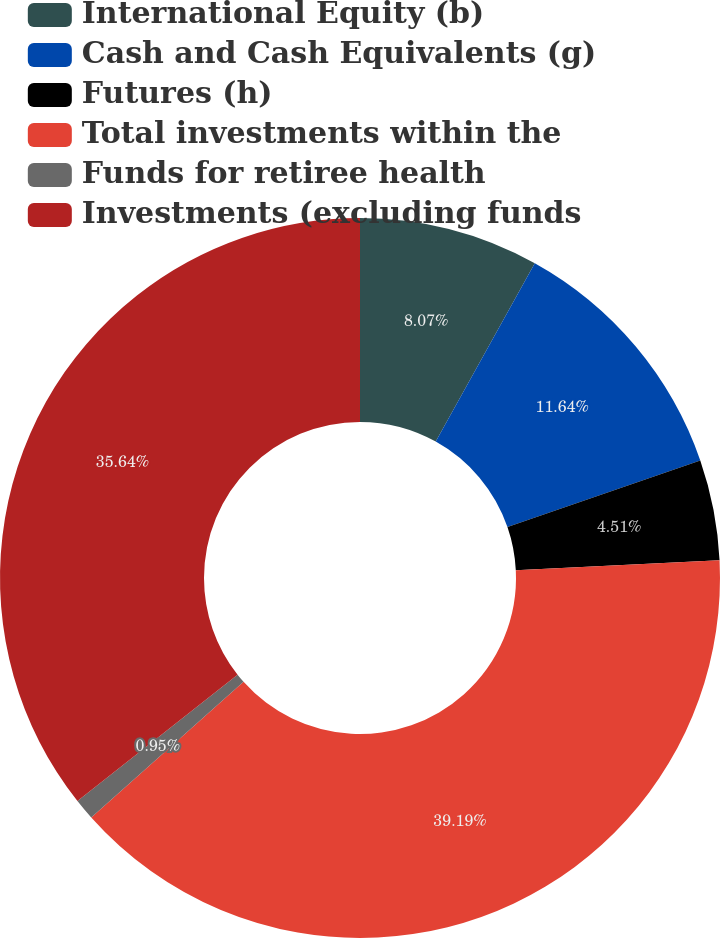Convert chart. <chart><loc_0><loc_0><loc_500><loc_500><pie_chart><fcel>International Equity (b)<fcel>Cash and Cash Equivalents (g)<fcel>Futures (h)<fcel>Total investments within the<fcel>Funds for retiree health<fcel>Investments (excluding funds<nl><fcel>8.07%<fcel>11.64%<fcel>4.51%<fcel>39.2%<fcel>0.95%<fcel>35.64%<nl></chart> 